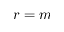<formula> <loc_0><loc_0><loc_500><loc_500>r = m</formula> 